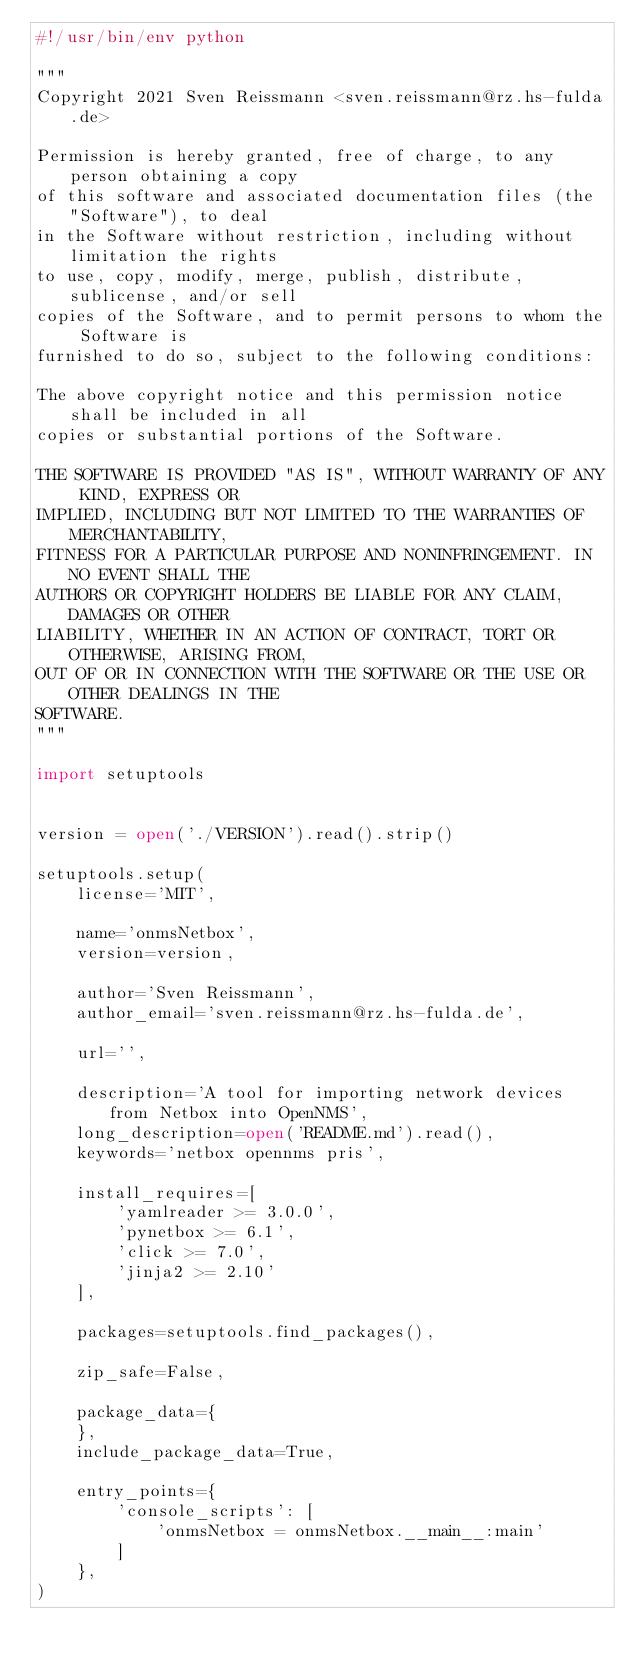Convert code to text. <code><loc_0><loc_0><loc_500><loc_500><_Python_>#!/usr/bin/env python

"""
Copyright 2021 Sven Reissmann <sven.reissmann@rz.hs-fulda.de>

Permission is hereby granted, free of charge, to any person obtaining a copy
of this software and associated documentation files (the "Software"), to deal
in the Software without restriction, including without limitation the rights
to use, copy, modify, merge, publish, distribute, sublicense, and/or sell
copies of the Software, and to permit persons to whom the Software is
furnished to do so, subject to the following conditions:

The above copyright notice and this permission notice shall be included in all
copies or substantial portions of the Software.

THE SOFTWARE IS PROVIDED "AS IS", WITHOUT WARRANTY OF ANY KIND, EXPRESS OR
IMPLIED, INCLUDING BUT NOT LIMITED TO THE WARRANTIES OF MERCHANTABILITY,
FITNESS FOR A PARTICULAR PURPOSE AND NONINFRINGEMENT. IN NO EVENT SHALL THE
AUTHORS OR COPYRIGHT HOLDERS BE LIABLE FOR ANY CLAIM, DAMAGES OR OTHER
LIABILITY, WHETHER IN AN ACTION OF CONTRACT, TORT OR OTHERWISE, ARISING FROM,
OUT OF OR IN CONNECTION WITH THE SOFTWARE OR THE USE OR OTHER DEALINGS IN THE
SOFTWARE.
"""

import setuptools


version = open('./VERSION').read().strip()

setuptools.setup(
    license='MIT',

    name='onmsNetbox',
    version=version,

    author='Sven Reissmann',
    author_email='sven.reissmann@rz.hs-fulda.de',

    url='',

    description='A tool for importing network devices from Netbox into OpenNMS',
    long_description=open('README.md').read(),
    keywords='netbox opennms pris',

    install_requires=[
        'yamlreader >= 3.0.0',
        'pynetbox >= 6.1',
        'click >= 7.0',
        'jinja2 >= 2.10'
    ],

    packages=setuptools.find_packages(),

    zip_safe=False,

    package_data={
    },
    include_package_data=True,

    entry_points={
        'console_scripts': [
            'onmsNetbox = onmsNetbox.__main__:main'
        ]
    },
)
</code> 